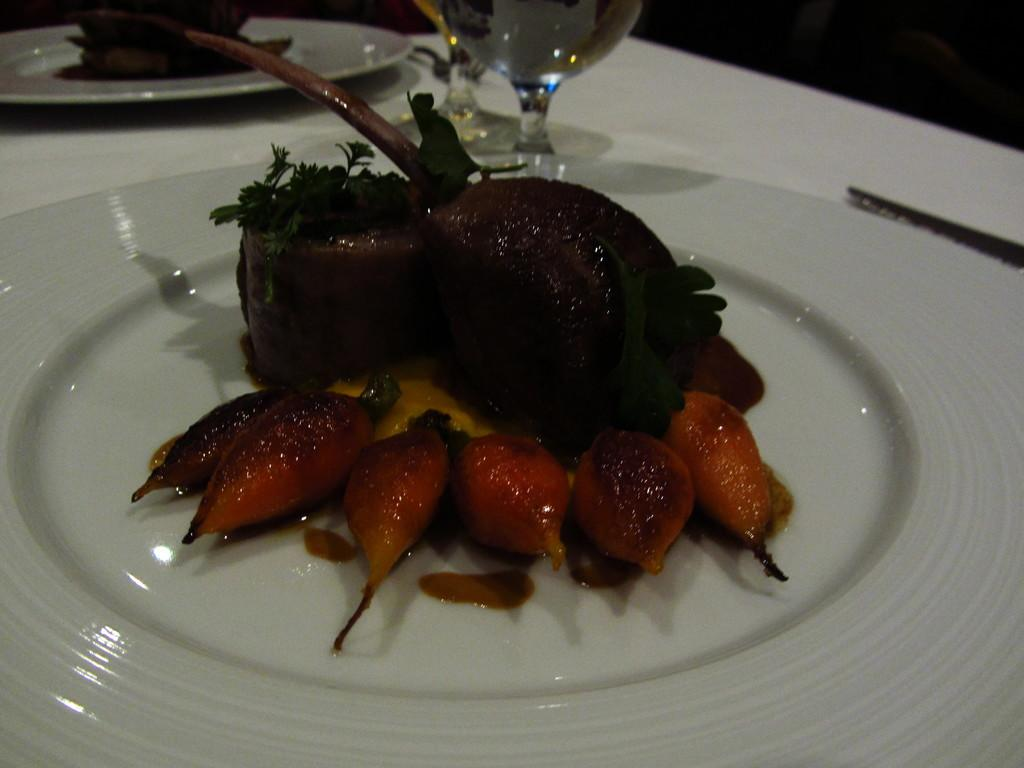What is placed on the white color plate in the image? There is a food item placed on a white color plate in the image. What can be seen at the top of the image? There is a glass and a spoon at the top of the image. Are there any other plates with food items in the image? Yes, there is another food item in a white color plate at the top of the image. What type of bean is stored in the drawer in the image? There is no bean or drawer present in the image. What role does the calculator play in the image? There is no calculator present in the image. 